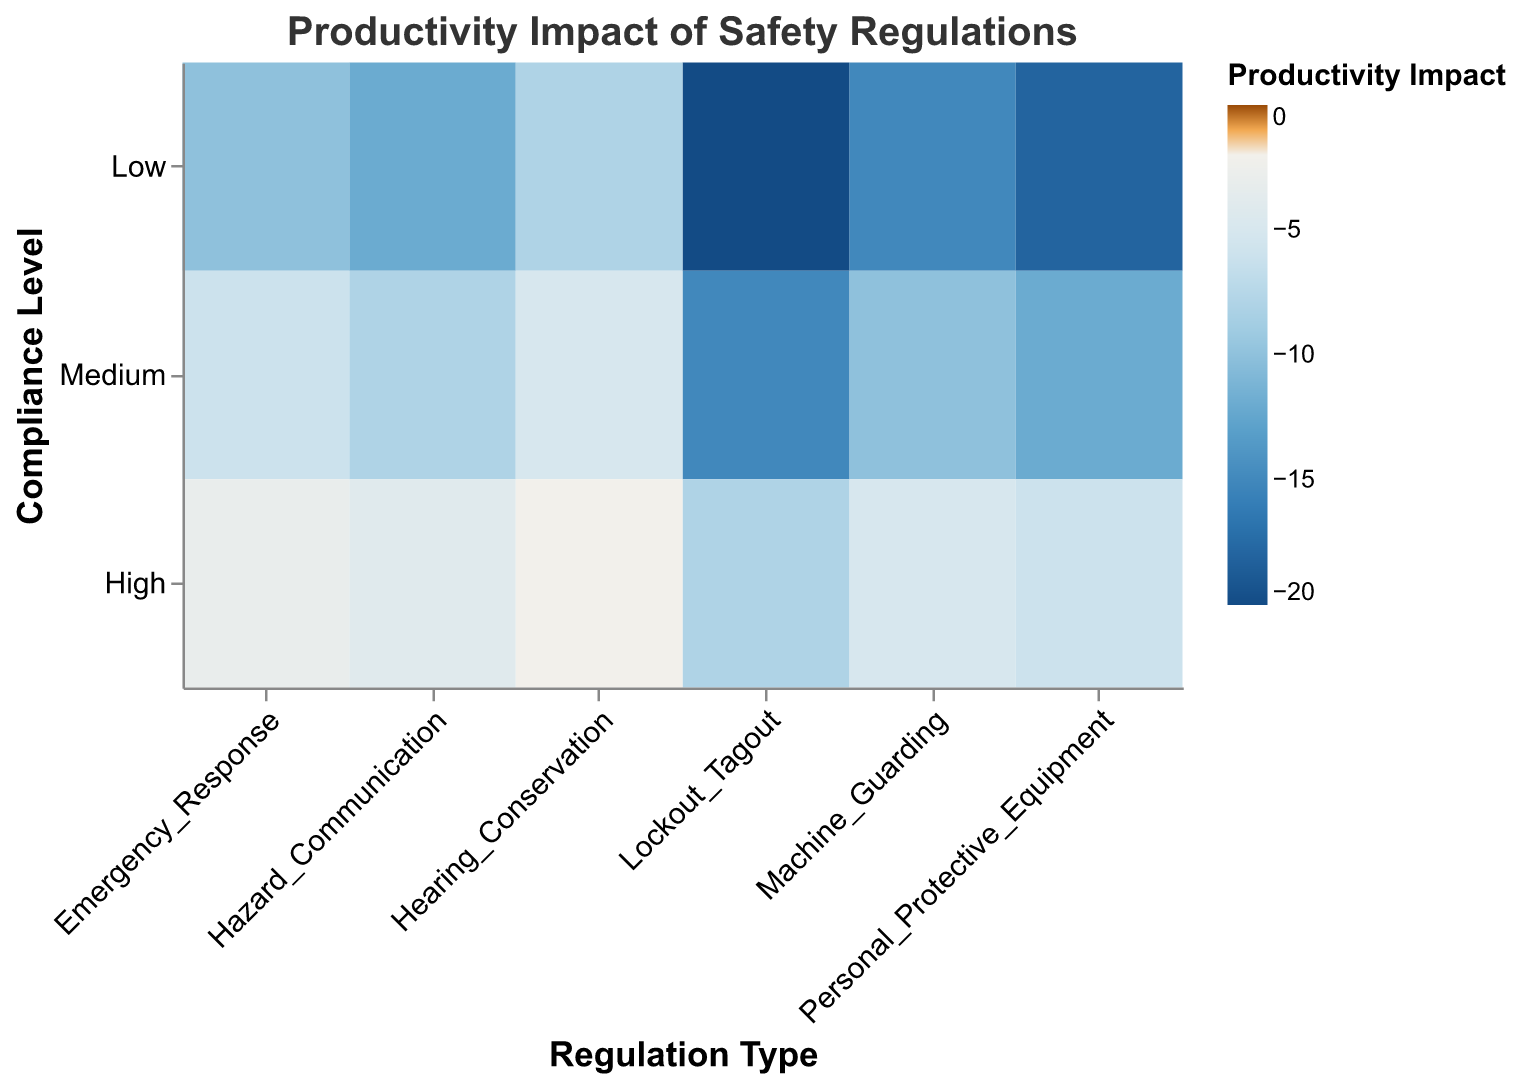What is the title of the heatmap? The title is displayed at the top of the figure, indicating the main focus of the visual representation.
Answer: Productivity Impact of Safety Regulations What are the compliance levels shown on the y-axis? The y-axis represents the compliance levels, which are labeled to the left of the heatmap.
Answer: Low, Medium, High Which regulation type has the least negative impact on productivity at high compliance levels? By observing the heatmap and focusing on the "High" compliance level, we can find the regulation type with the least negative productivity impact color.
Answer: Hearing Conservation What is the productivity impact for Lockout_Tagout at a medium compliance level? Locate the "Lockout_Tagout" column and find the cell corresponding to "Medium" compliance level, then identify the color representing productivity impact.
Answer: -15 How does the productivity impact of Emergency_Response compare to Machine_Guarding at low compliance levels? Compare the colors and values of Emergency_Response and Machine_Guarding in the "Low" compliance level row.
Answer: Emergency_Response: -10, Machine_Guarding: -15; Emergency_Response has a less negative impact Which compliance level category has the smallest overall productivity impact for all regulation types? Sum the productivity impacts for each compliance level across all regulation types and find the one with the least negative sum.
Answer: High Which regulation type shows the largest decrease in productivity impact when moving from low to high compliance levels? Calculate the difference between the productivity impacts at "Low" and "High" compliance levels for each regulation type and determine the largest decrease.
Answer: Lockout_Tagout (from -20 to -8, difference of 12) What colors are used to represent productivity impact values? Identify the color scheme used to indicate different levels of productivity impact on the heatmap.
Answer: Blue and Orange What is the range of productivity impact values represented on the heatmap? Examine the legend to determine the minimum and maximum productivity impact values shown on the figure.
Answer: -20 to -2 